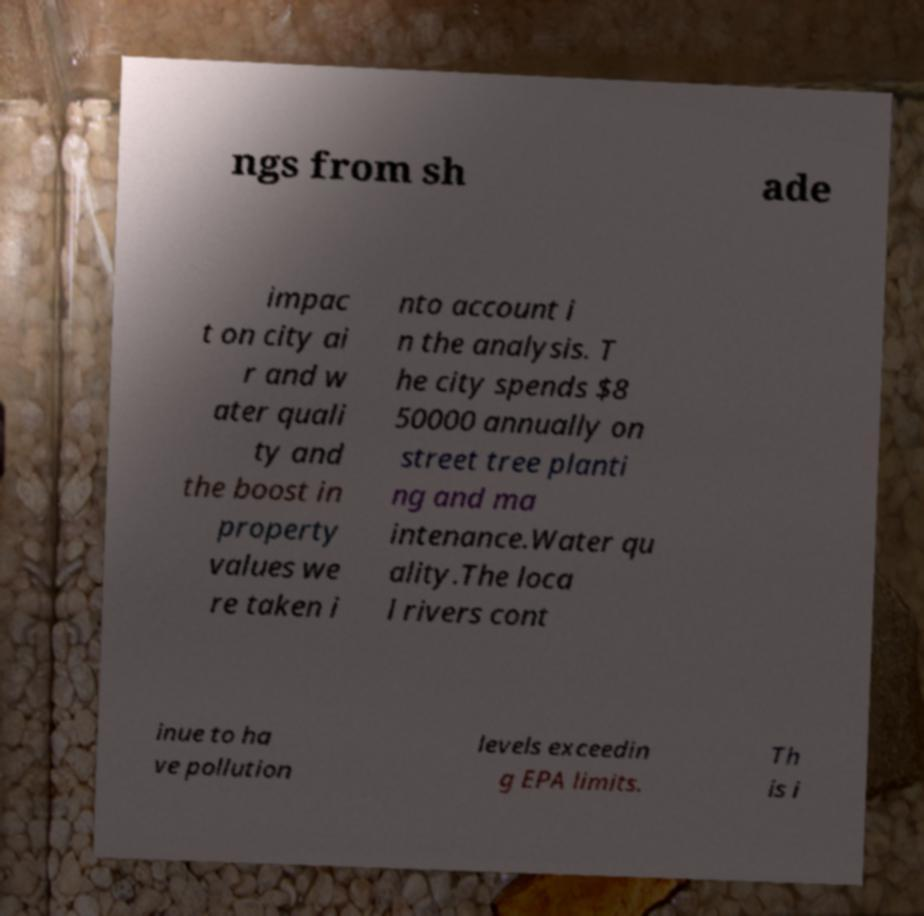What messages or text are displayed in this image? I need them in a readable, typed format. ngs from sh ade impac t on city ai r and w ater quali ty and the boost in property values we re taken i nto account i n the analysis. T he city spends $8 50000 annually on street tree planti ng and ma intenance.Water qu ality.The loca l rivers cont inue to ha ve pollution levels exceedin g EPA limits. Th is i 